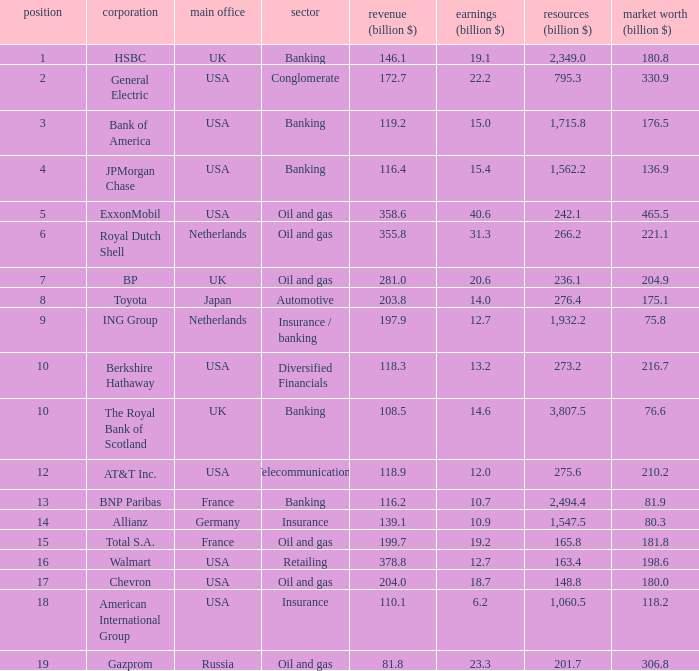What is the market capitalization of a company in billions with 17 330.9. 